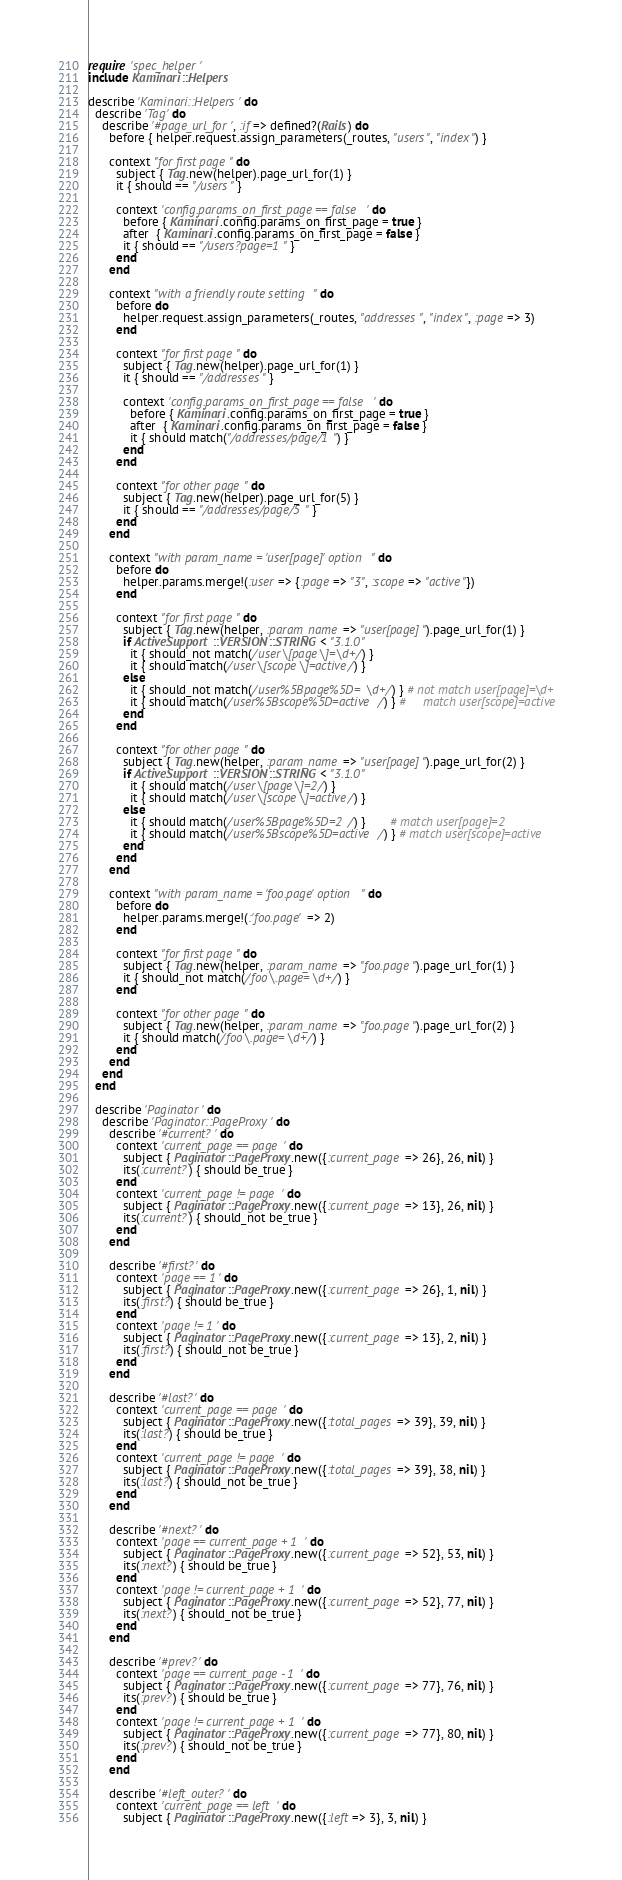Convert code to text. <code><loc_0><loc_0><loc_500><loc_500><_Ruby_>require 'spec_helper'
include Kaminari::Helpers

describe 'Kaminari::Helpers' do
  describe 'Tag' do
    describe '#page_url_for', :if => defined?(Rails) do
      before { helper.request.assign_parameters(_routes, "users", "index") }

      context "for first page" do
        subject { Tag.new(helper).page_url_for(1) }
        it { should == "/users" }

        context 'config.params_on_first_page == false' do
          before { Kaminari.config.params_on_first_page = true }
          after  { Kaminari.config.params_on_first_page = false }
          it { should == "/users?page=1" }
        end
      end

      context "with a friendly route setting" do
        before do
          helper.request.assign_parameters(_routes, "addresses", "index", :page => 3)
        end

        context "for first page" do
          subject { Tag.new(helper).page_url_for(1) }
          it { should == "/addresses" }

          context 'config.params_on_first_page == false' do
            before { Kaminari.config.params_on_first_page = true }
            after  { Kaminari.config.params_on_first_page = false }
            it { should match("/addresses/page/1") }
          end
        end

        context "for other page" do
          subject { Tag.new(helper).page_url_for(5) }
          it { should == "/addresses/page/5" }
        end
      end

      context "with param_name = 'user[page]' option" do
        before do
          helper.params.merge!(:user => {:page => "3", :scope => "active"})
        end

        context "for first page" do
          subject { Tag.new(helper, :param_name => "user[page]").page_url_for(1) }
          if ActiveSupport::VERSION::STRING < "3.1.0"
            it { should_not match(/user\[page\]=\d+/) }
            it { should match(/user\[scope\]=active/) }
          else
            it { should_not match(/user%5Bpage%5D=\d+/) } # not match user[page]=\d+
            it { should match(/user%5Bscope%5D=active/) } #     match user[scope]=active
          end
        end

        context "for other page" do
          subject { Tag.new(helper, :param_name => "user[page]").page_url_for(2) }
          if ActiveSupport::VERSION::STRING < "3.1.0"
            it { should match(/user\[page\]=2/) }
            it { should match(/user\[scope\]=active/) }
          else
            it { should match(/user%5Bpage%5D=2/) }       # match user[page]=2
            it { should match(/user%5Bscope%5D=active/) } # match user[scope]=active
          end
        end
      end

      context "with param_name = 'foo.page' option" do
        before do
          helper.params.merge!(:'foo.page' => 2)
        end

        context "for first page" do
          subject { Tag.new(helper, :param_name => "foo.page").page_url_for(1) }
          it { should_not match(/foo\.page=\d+/) }
        end

        context "for other page" do
          subject { Tag.new(helper, :param_name => "foo.page").page_url_for(2) }
          it { should match(/foo\.page=\d+/) }
        end
      end
    end
  end

  describe 'Paginator' do
    describe 'Paginator::PageProxy' do
      describe '#current?' do
        context 'current_page == page' do
          subject { Paginator::PageProxy.new({:current_page => 26}, 26, nil) }
          its(:current?) { should be_true }
        end
        context 'current_page != page' do
          subject { Paginator::PageProxy.new({:current_page => 13}, 26, nil) }
          its(:current?) { should_not be_true }
        end
      end

      describe '#first?' do
        context 'page == 1' do
          subject { Paginator::PageProxy.new({:current_page => 26}, 1, nil) }
          its(:first?) { should be_true }
        end
        context 'page != 1' do
          subject { Paginator::PageProxy.new({:current_page => 13}, 2, nil) }
          its(:first?) { should_not be_true }
        end
      end

      describe '#last?' do
        context 'current_page == page' do
          subject { Paginator::PageProxy.new({:total_pages => 39}, 39, nil) }
          its(:last?) { should be_true }
        end
        context 'current_page != page' do
          subject { Paginator::PageProxy.new({:total_pages => 39}, 38, nil) }
          its(:last?) { should_not be_true }
        end
      end

      describe '#next?' do
        context 'page == current_page + 1' do
          subject { Paginator::PageProxy.new({:current_page => 52}, 53, nil) }
          its(:next?) { should be_true }
        end
        context 'page != current_page + 1' do
          subject { Paginator::PageProxy.new({:current_page => 52}, 77, nil) }
          its(:next?) { should_not be_true }
        end
      end

      describe '#prev?' do
        context 'page == current_page - 1' do
          subject { Paginator::PageProxy.new({:current_page => 77}, 76, nil) }
          its(:prev?) { should be_true }
        end
        context 'page != current_page + 1' do
          subject { Paginator::PageProxy.new({:current_page => 77}, 80, nil) }
          its(:prev?) { should_not be_true }
        end
      end

      describe '#left_outer?' do
        context 'current_page == left' do
          subject { Paginator::PageProxy.new({:left => 3}, 3, nil) }</code> 